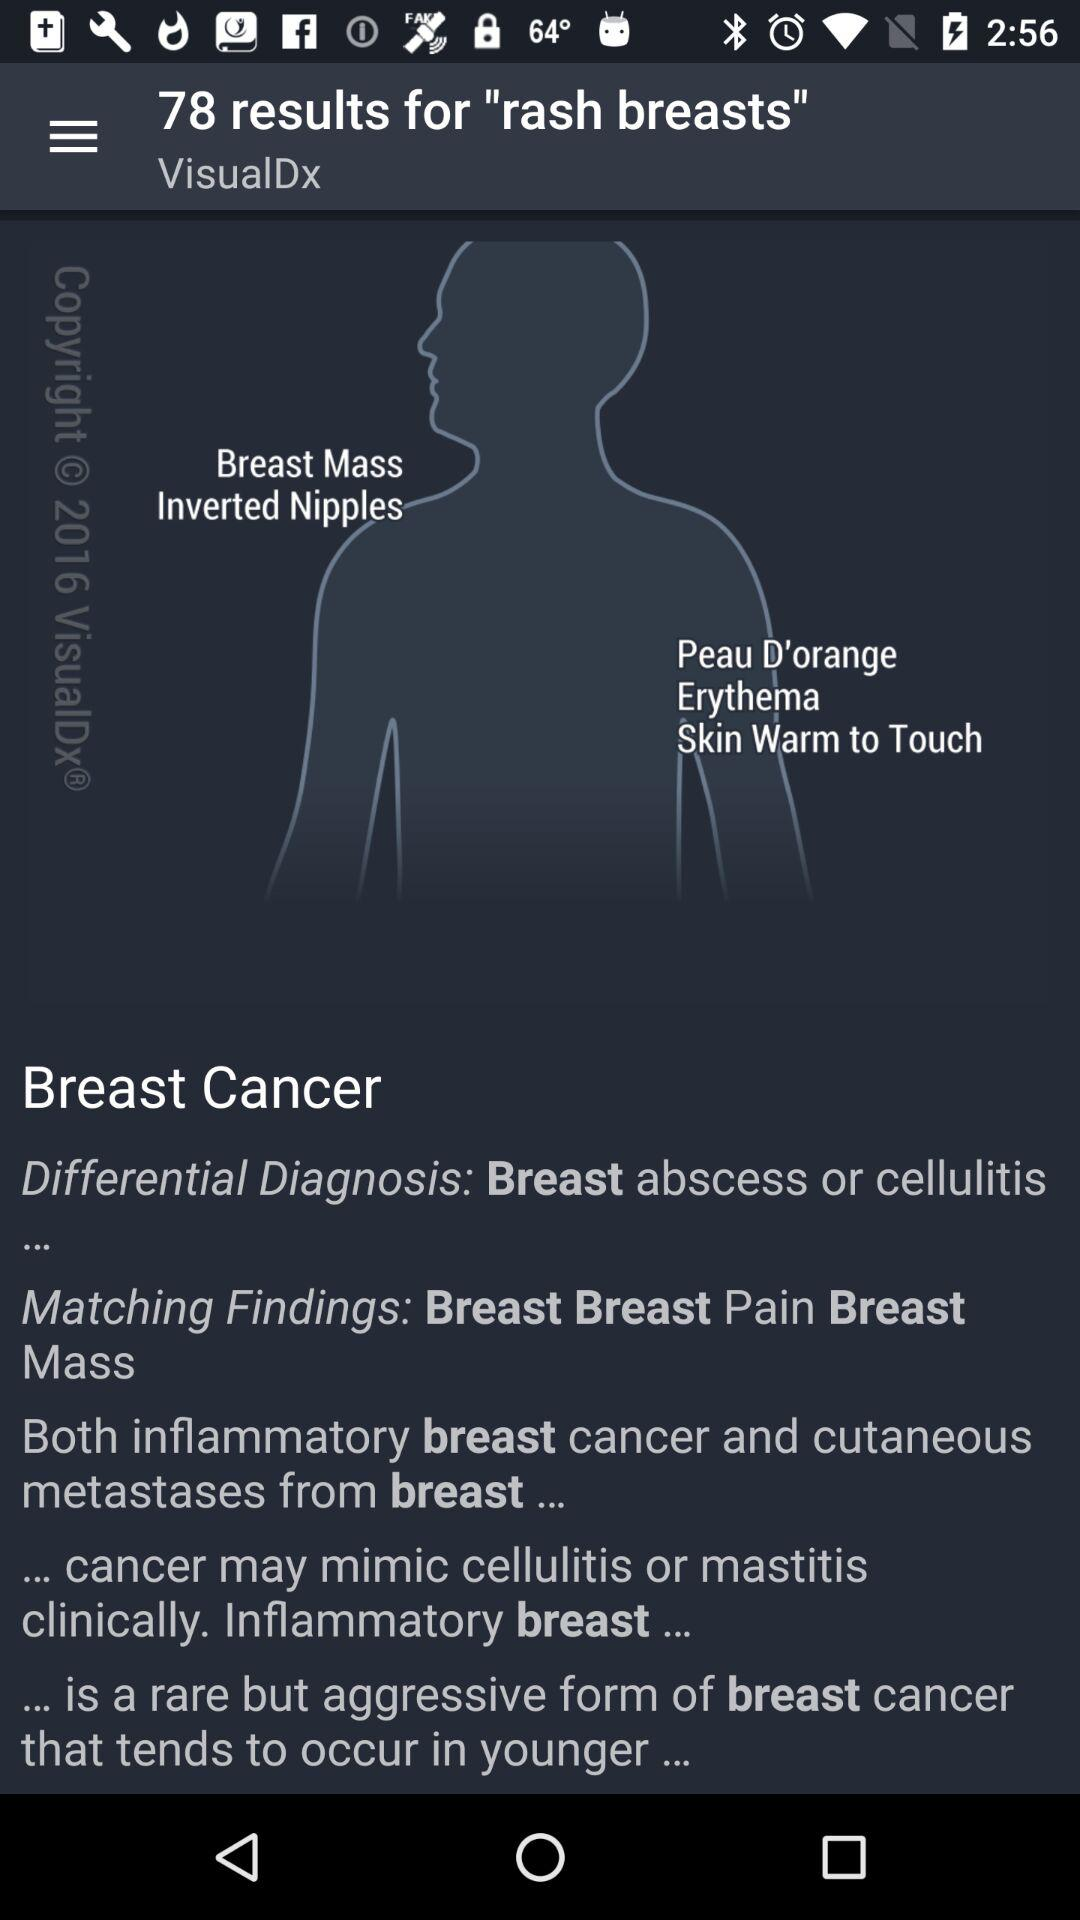What is the application name? The application name is "VisualDx". 